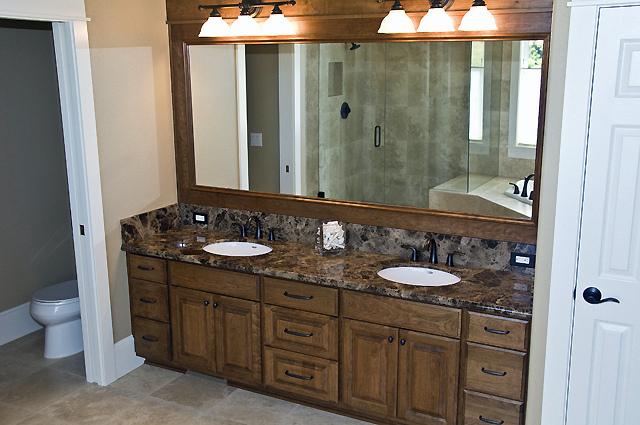What are the countertops made of?
Write a very short answer. Marble. What are the cabinets made of?
Keep it brief. Wood. What room is this?
Write a very short answer. Bathroom. 